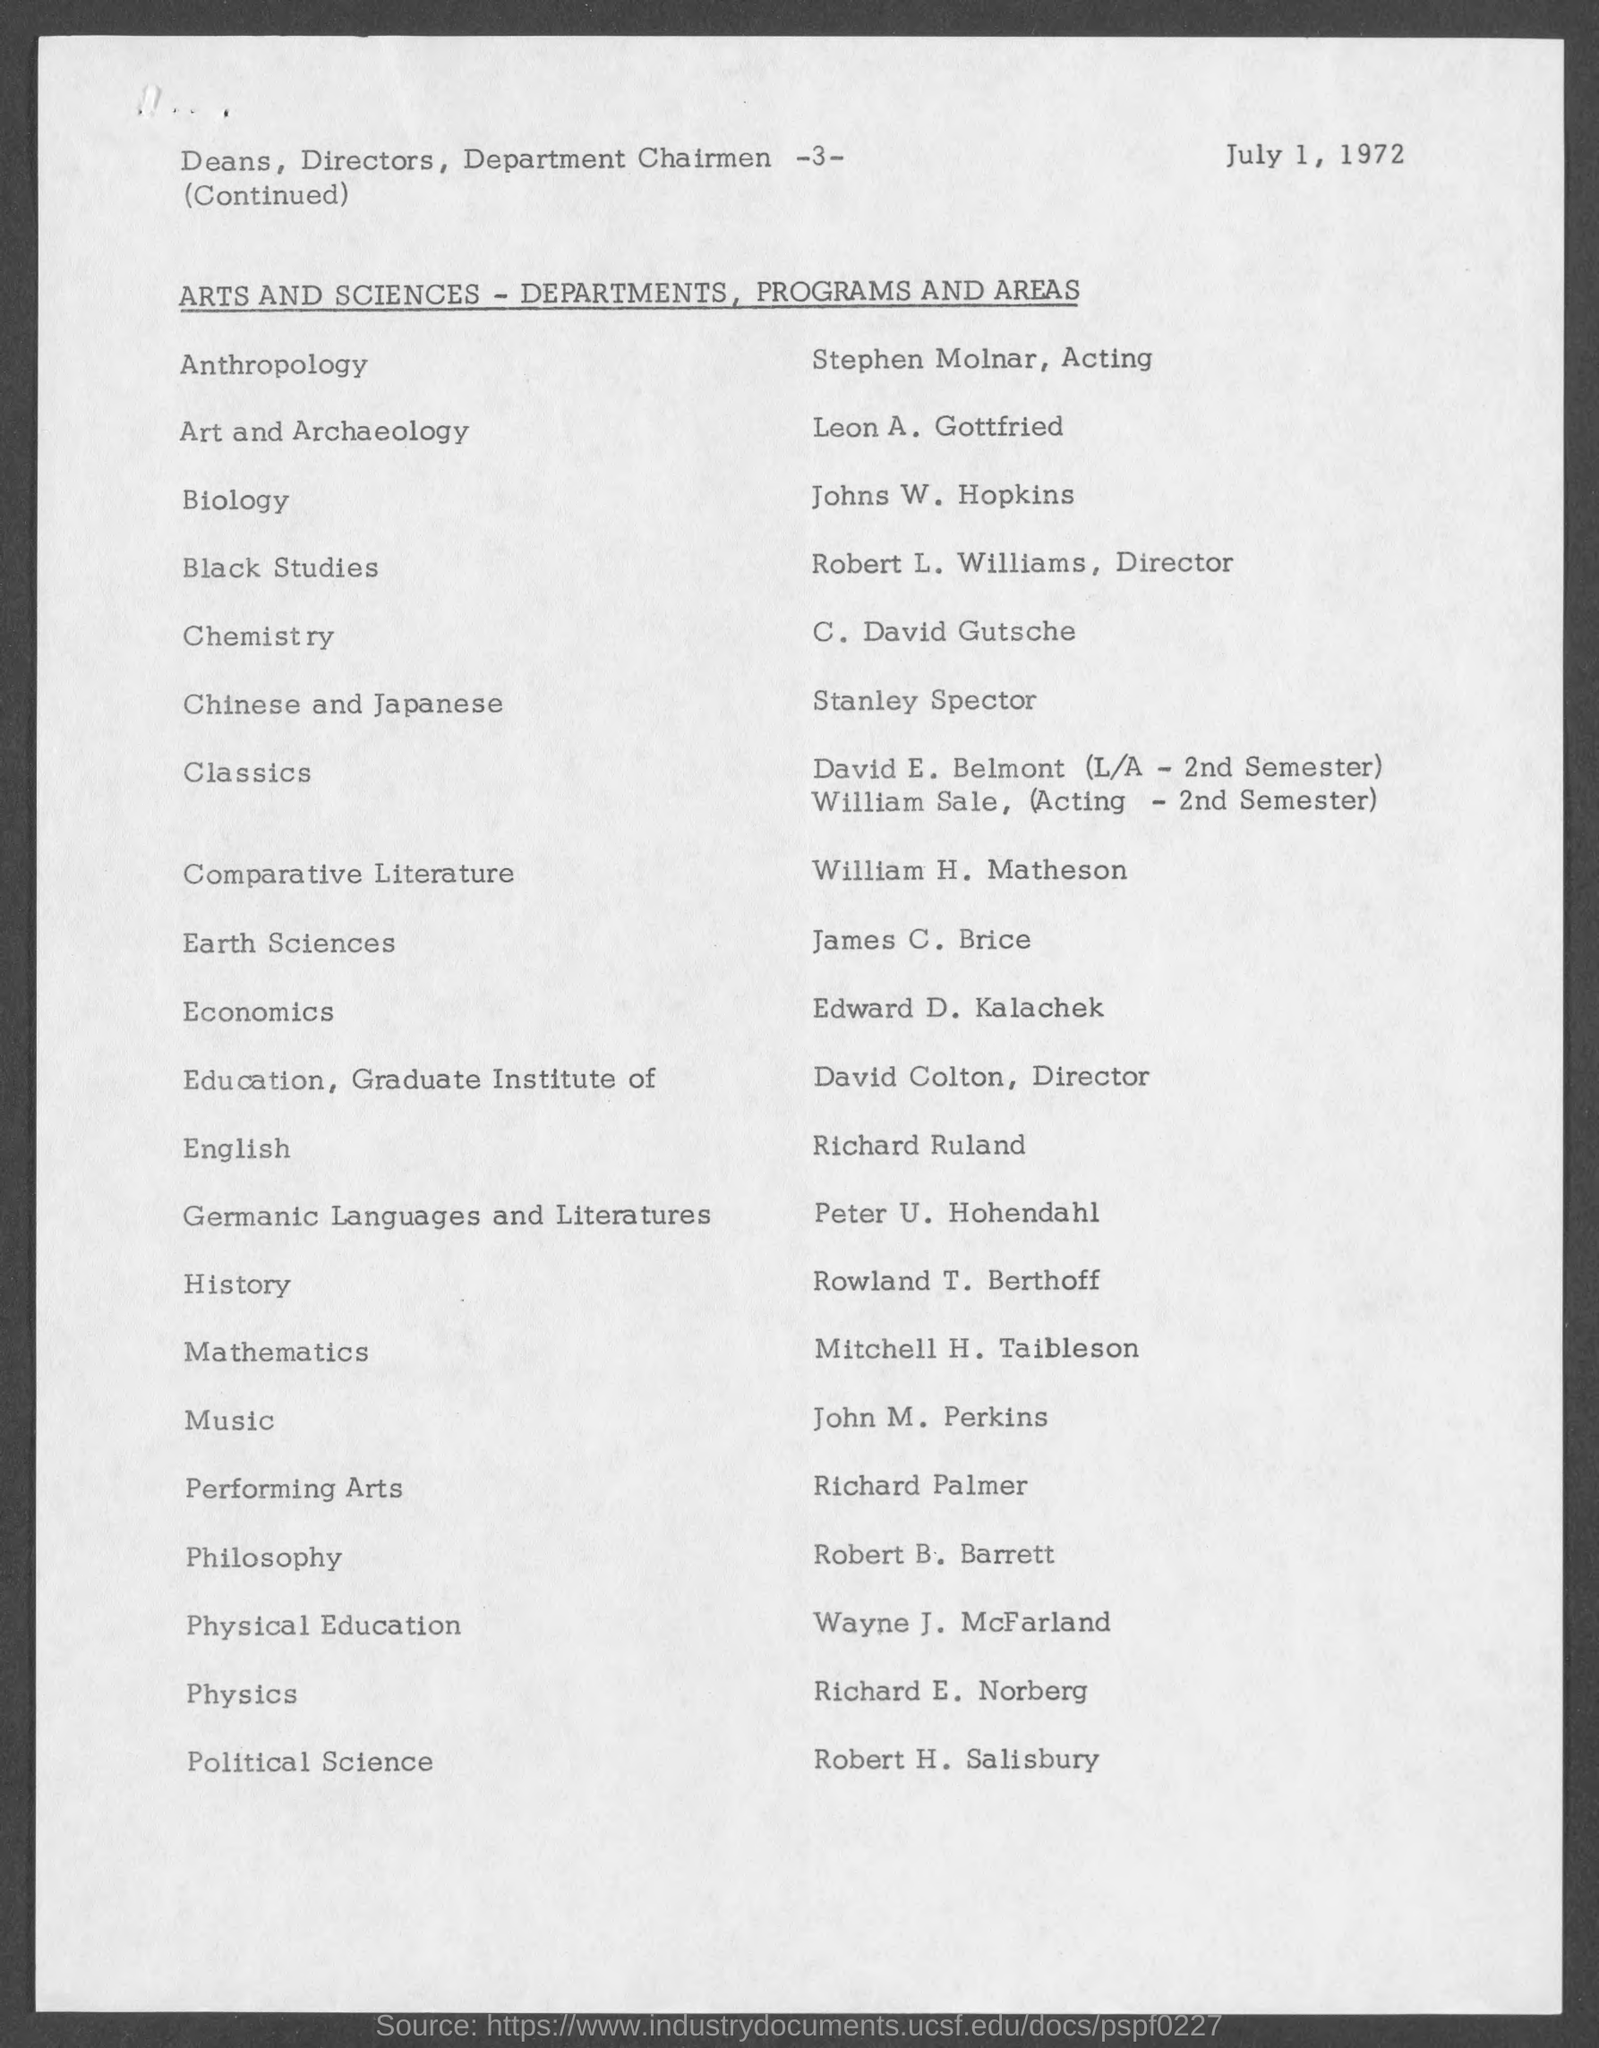Outline some significant characteristics in this image. The date mentioned in the document is July 1, 1972. John W. Hopkins is employed in the field of biology. Robert H. Salisbury works in the department of Political Science. 